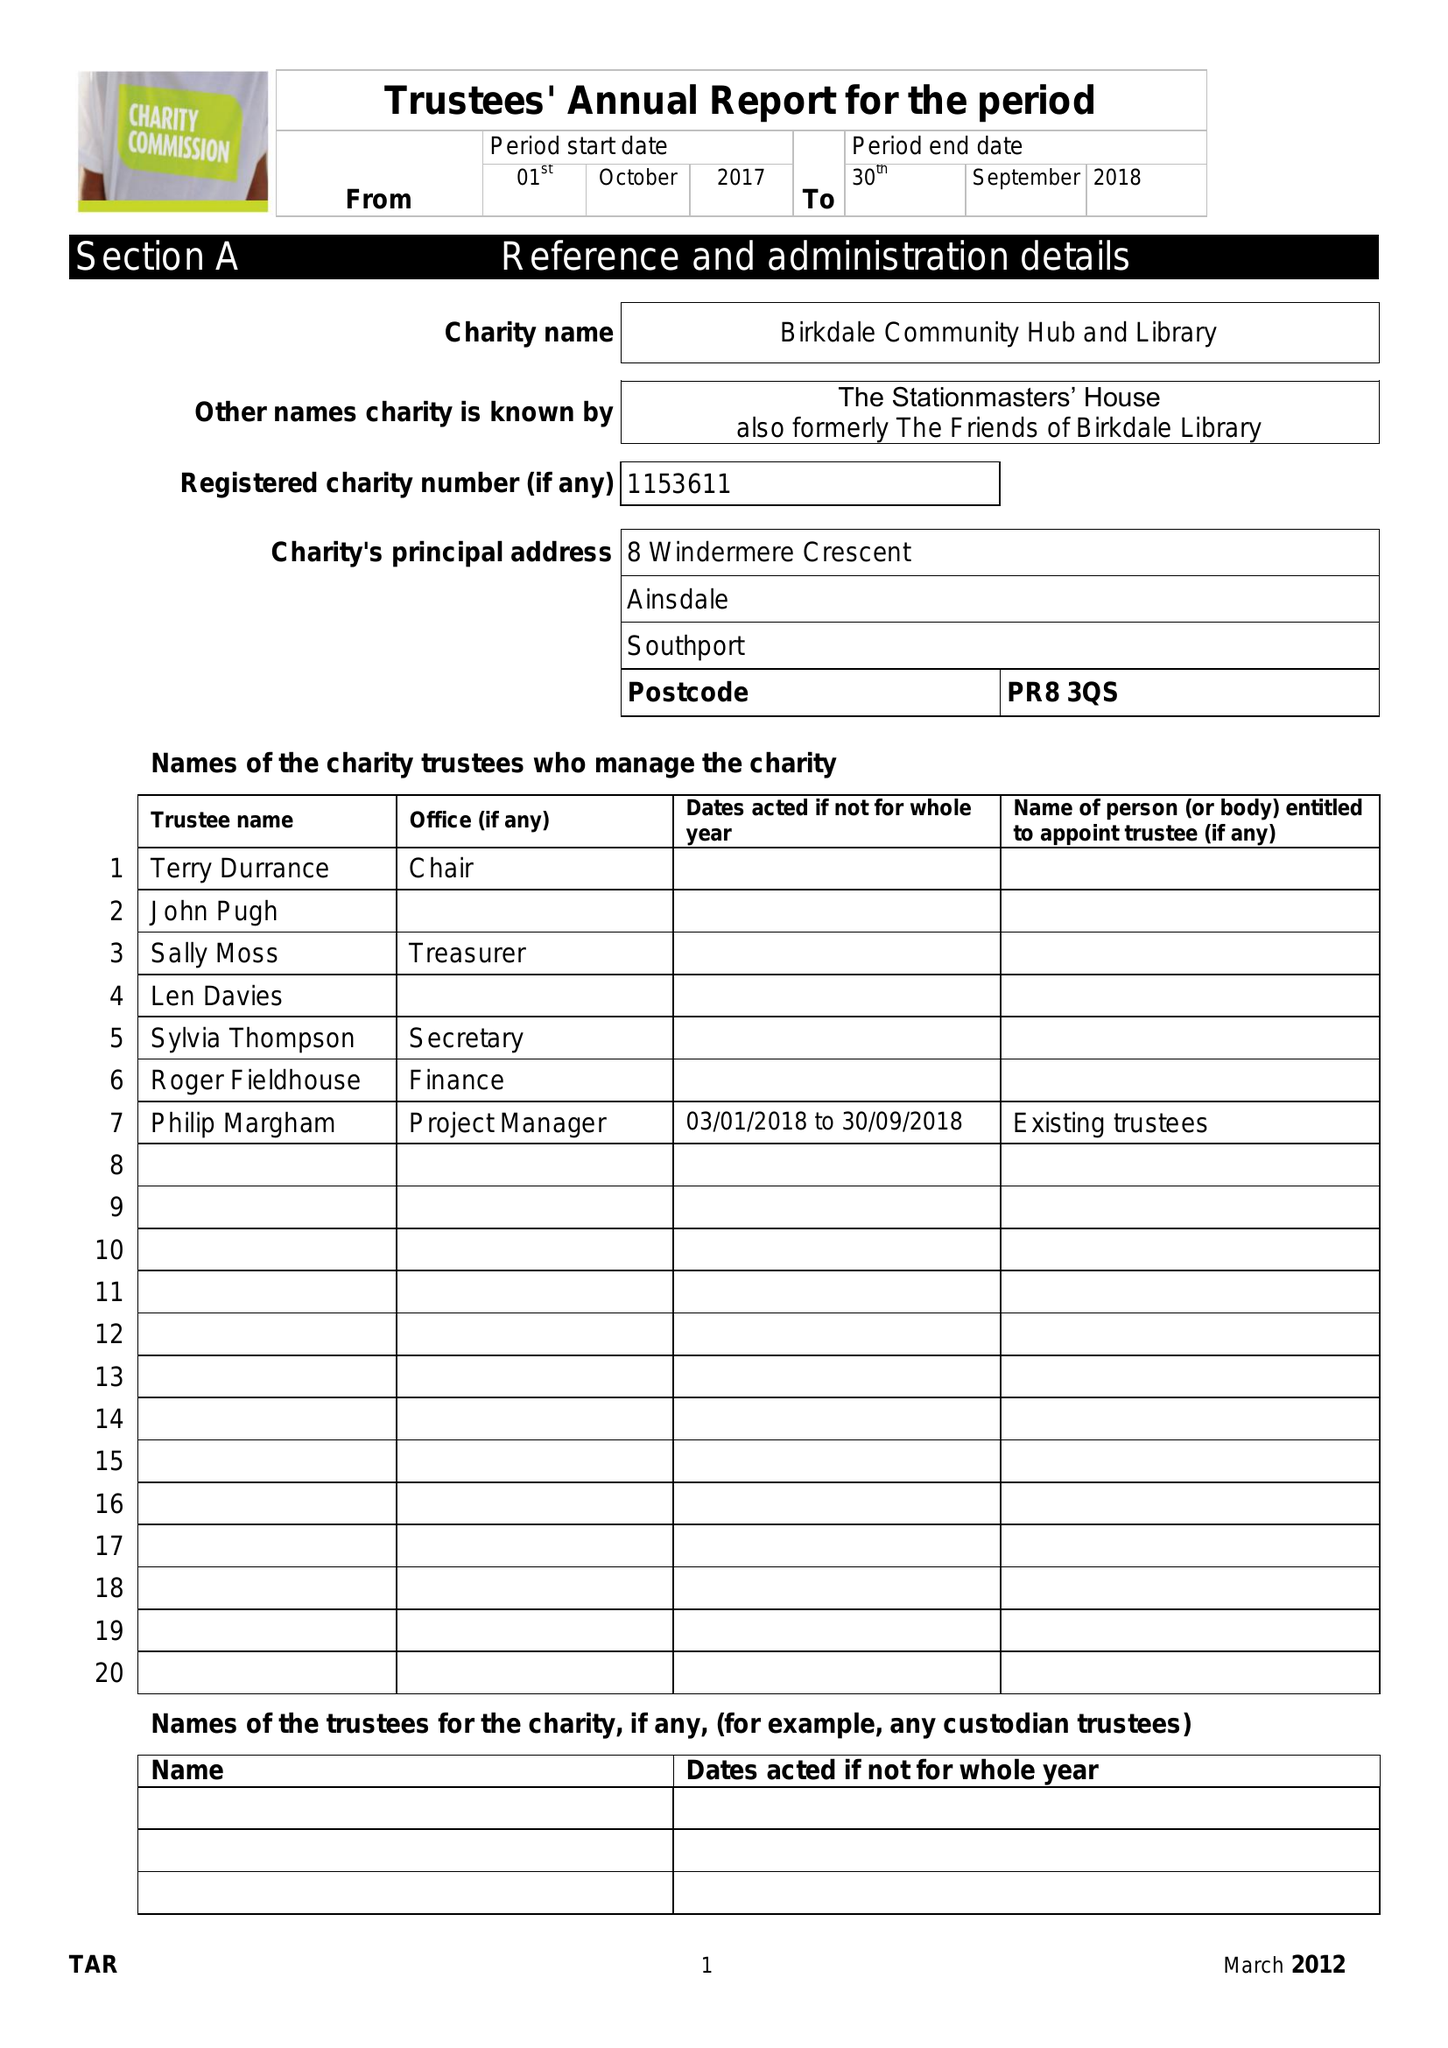What is the value for the address__street_line?
Answer the question using a single word or phrase. None 